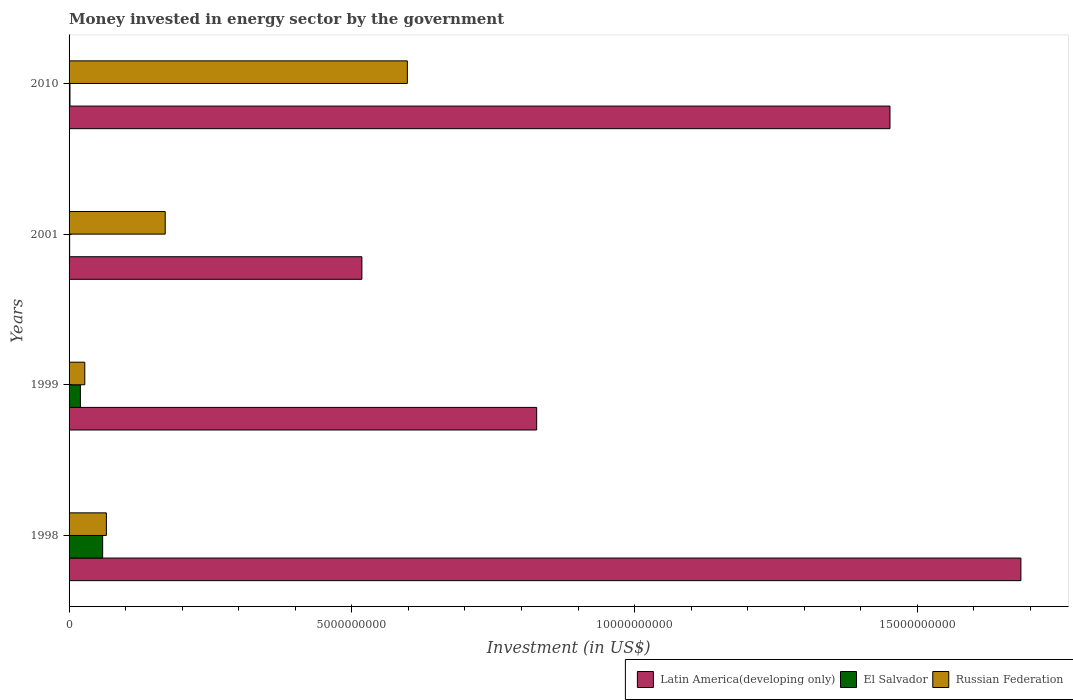What is the money spent in energy sector in Latin America(developing only) in 2001?
Ensure brevity in your answer.  5.18e+09. Across all years, what is the maximum money spent in energy sector in Russian Federation?
Give a very brief answer. 5.98e+09. In which year was the money spent in energy sector in Russian Federation maximum?
Your answer should be very brief. 2010. What is the total money spent in energy sector in El Salvador in the graph?
Your response must be concise. 8.20e+08. What is the difference between the money spent in energy sector in Latin America(developing only) in 1999 and that in 2001?
Your answer should be compact. 3.09e+09. What is the difference between the money spent in energy sector in Latin America(developing only) in 1998 and the money spent in energy sector in El Salvador in 2001?
Provide a short and direct response. 1.68e+1. What is the average money spent in energy sector in El Salvador per year?
Your answer should be compact. 2.05e+08. In the year 1998, what is the difference between the money spent in energy sector in El Salvador and money spent in energy sector in Russian Federation?
Your answer should be compact. -6.60e+07. In how many years, is the money spent in energy sector in Russian Federation greater than 9000000000 US$?
Provide a succinct answer. 0. What is the ratio of the money spent in energy sector in El Salvador in 1999 to that in 2001?
Ensure brevity in your answer.  20.02. Is the difference between the money spent in energy sector in El Salvador in 1999 and 2001 greater than the difference between the money spent in energy sector in Russian Federation in 1999 and 2001?
Your answer should be compact. Yes. What is the difference between the highest and the second highest money spent in energy sector in El Salvador?
Your answer should be very brief. 3.94e+08. What is the difference between the highest and the lowest money spent in energy sector in El Salvador?
Provide a short and direct response. 5.84e+08. What does the 2nd bar from the top in 1998 represents?
Offer a terse response. El Salvador. What does the 3rd bar from the bottom in 1999 represents?
Keep it short and to the point. Russian Federation. Is it the case that in every year, the sum of the money spent in energy sector in El Salvador and money spent in energy sector in Latin America(developing only) is greater than the money spent in energy sector in Russian Federation?
Offer a terse response. Yes. How many bars are there?
Provide a succinct answer. 12. What is the difference between two consecutive major ticks on the X-axis?
Keep it short and to the point. 5.00e+09. Does the graph contain any zero values?
Offer a very short reply. No. Does the graph contain grids?
Your response must be concise. No. Where does the legend appear in the graph?
Provide a short and direct response. Bottom right. What is the title of the graph?
Provide a short and direct response. Money invested in energy sector by the government. What is the label or title of the X-axis?
Keep it short and to the point. Investment (in US$). What is the label or title of the Y-axis?
Your answer should be compact. Years. What is the Investment (in US$) of Latin America(developing only) in 1998?
Give a very brief answer. 1.68e+1. What is the Investment (in US$) of El Salvador in 1998?
Make the answer very short. 5.94e+08. What is the Investment (in US$) of Russian Federation in 1998?
Provide a short and direct response. 6.60e+08. What is the Investment (in US$) in Latin America(developing only) in 1999?
Keep it short and to the point. 8.27e+09. What is the Investment (in US$) of El Salvador in 1999?
Provide a succinct answer. 2.00e+08. What is the Investment (in US$) in Russian Federation in 1999?
Keep it short and to the point. 2.78e+08. What is the Investment (in US$) of Latin America(developing only) in 2001?
Offer a very short reply. 5.18e+09. What is the Investment (in US$) of Russian Federation in 2001?
Ensure brevity in your answer.  1.70e+09. What is the Investment (in US$) in Latin America(developing only) in 2010?
Keep it short and to the point. 1.45e+1. What is the Investment (in US$) in El Salvador in 2010?
Your answer should be very brief. 1.60e+07. What is the Investment (in US$) in Russian Federation in 2010?
Give a very brief answer. 5.98e+09. Across all years, what is the maximum Investment (in US$) of Latin America(developing only)?
Your answer should be very brief. 1.68e+1. Across all years, what is the maximum Investment (in US$) of El Salvador?
Your response must be concise. 5.94e+08. Across all years, what is the maximum Investment (in US$) in Russian Federation?
Provide a short and direct response. 5.98e+09. Across all years, what is the minimum Investment (in US$) of Latin America(developing only)?
Your answer should be very brief. 5.18e+09. Across all years, what is the minimum Investment (in US$) in El Salvador?
Provide a short and direct response. 1.00e+07. Across all years, what is the minimum Investment (in US$) in Russian Federation?
Your answer should be compact. 2.78e+08. What is the total Investment (in US$) of Latin America(developing only) in the graph?
Your response must be concise. 4.48e+1. What is the total Investment (in US$) of El Salvador in the graph?
Provide a succinct answer. 8.20e+08. What is the total Investment (in US$) in Russian Federation in the graph?
Your answer should be very brief. 8.62e+09. What is the difference between the Investment (in US$) of Latin America(developing only) in 1998 and that in 1999?
Provide a succinct answer. 8.56e+09. What is the difference between the Investment (in US$) in El Salvador in 1998 and that in 1999?
Your answer should be compact. 3.94e+08. What is the difference between the Investment (in US$) of Russian Federation in 1998 and that in 1999?
Provide a succinct answer. 3.82e+08. What is the difference between the Investment (in US$) of Latin America(developing only) in 1998 and that in 2001?
Give a very brief answer. 1.17e+1. What is the difference between the Investment (in US$) in El Salvador in 1998 and that in 2001?
Provide a short and direct response. 5.84e+08. What is the difference between the Investment (in US$) of Russian Federation in 1998 and that in 2001?
Your answer should be very brief. -1.04e+09. What is the difference between the Investment (in US$) of Latin America(developing only) in 1998 and that in 2010?
Your response must be concise. 2.31e+09. What is the difference between the Investment (in US$) in El Salvador in 1998 and that in 2010?
Keep it short and to the point. 5.78e+08. What is the difference between the Investment (in US$) in Russian Federation in 1998 and that in 2010?
Make the answer very short. -5.32e+09. What is the difference between the Investment (in US$) of Latin America(developing only) in 1999 and that in 2001?
Provide a short and direct response. 3.09e+09. What is the difference between the Investment (in US$) of El Salvador in 1999 and that in 2001?
Make the answer very short. 1.90e+08. What is the difference between the Investment (in US$) in Russian Federation in 1999 and that in 2001?
Ensure brevity in your answer.  -1.42e+09. What is the difference between the Investment (in US$) in Latin America(developing only) in 1999 and that in 2010?
Your response must be concise. -6.25e+09. What is the difference between the Investment (in US$) of El Salvador in 1999 and that in 2010?
Ensure brevity in your answer.  1.84e+08. What is the difference between the Investment (in US$) of Russian Federation in 1999 and that in 2010?
Make the answer very short. -5.70e+09. What is the difference between the Investment (in US$) in Latin America(developing only) in 2001 and that in 2010?
Ensure brevity in your answer.  -9.34e+09. What is the difference between the Investment (in US$) in El Salvador in 2001 and that in 2010?
Keep it short and to the point. -6.00e+06. What is the difference between the Investment (in US$) in Russian Federation in 2001 and that in 2010?
Your answer should be very brief. -4.28e+09. What is the difference between the Investment (in US$) in Latin America(developing only) in 1998 and the Investment (in US$) in El Salvador in 1999?
Make the answer very short. 1.66e+1. What is the difference between the Investment (in US$) in Latin America(developing only) in 1998 and the Investment (in US$) in Russian Federation in 1999?
Give a very brief answer. 1.66e+1. What is the difference between the Investment (in US$) of El Salvador in 1998 and the Investment (in US$) of Russian Federation in 1999?
Make the answer very short. 3.16e+08. What is the difference between the Investment (in US$) of Latin America(developing only) in 1998 and the Investment (in US$) of El Salvador in 2001?
Offer a very short reply. 1.68e+1. What is the difference between the Investment (in US$) of Latin America(developing only) in 1998 and the Investment (in US$) of Russian Federation in 2001?
Make the answer very short. 1.51e+1. What is the difference between the Investment (in US$) in El Salvador in 1998 and the Investment (in US$) in Russian Federation in 2001?
Make the answer very short. -1.11e+09. What is the difference between the Investment (in US$) in Latin America(developing only) in 1998 and the Investment (in US$) in El Salvador in 2010?
Ensure brevity in your answer.  1.68e+1. What is the difference between the Investment (in US$) in Latin America(developing only) in 1998 and the Investment (in US$) in Russian Federation in 2010?
Offer a very short reply. 1.08e+1. What is the difference between the Investment (in US$) of El Salvador in 1998 and the Investment (in US$) of Russian Federation in 2010?
Give a very brief answer. -5.39e+09. What is the difference between the Investment (in US$) of Latin America(developing only) in 1999 and the Investment (in US$) of El Salvador in 2001?
Keep it short and to the point. 8.26e+09. What is the difference between the Investment (in US$) in Latin America(developing only) in 1999 and the Investment (in US$) in Russian Federation in 2001?
Make the answer very short. 6.57e+09. What is the difference between the Investment (in US$) in El Salvador in 1999 and the Investment (in US$) in Russian Federation in 2001?
Offer a terse response. -1.50e+09. What is the difference between the Investment (in US$) of Latin America(developing only) in 1999 and the Investment (in US$) of El Salvador in 2010?
Keep it short and to the point. 8.25e+09. What is the difference between the Investment (in US$) in Latin America(developing only) in 1999 and the Investment (in US$) in Russian Federation in 2010?
Ensure brevity in your answer.  2.29e+09. What is the difference between the Investment (in US$) in El Salvador in 1999 and the Investment (in US$) in Russian Federation in 2010?
Provide a succinct answer. -5.78e+09. What is the difference between the Investment (in US$) of Latin America(developing only) in 2001 and the Investment (in US$) of El Salvador in 2010?
Offer a very short reply. 5.16e+09. What is the difference between the Investment (in US$) in Latin America(developing only) in 2001 and the Investment (in US$) in Russian Federation in 2010?
Keep it short and to the point. -8.04e+08. What is the difference between the Investment (in US$) of El Salvador in 2001 and the Investment (in US$) of Russian Federation in 2010?
Provide a short and direct response. -5.97e+09. What is the average Investment (in US$) of Latin America(developing only) per year?
Your answer should be compact. 1.12e+1. What is the average Investment (in US$) of El Salvador per year?
Ensure brevity in your answer.  2.05e+08. What is the average Investment (in US$) of Russian Federation per year?
Offer a very short reply. 2.15e+09. In the year 1998, what is the difference between the Investment (in US$) of Latin America(developing only) and Investment (in US$) of El Salvador?
Make the answer very short. 1.62e+1. In the year 1998, what is the difference between the Investment (in US$) of Latin America(developing only) and Investment (in US$) of Russian Federation?
Offer a very short reply. 1.62e+1. In the year 1998, what is the difference between the Investment (in US$) in El Salvador and Investment (in US$) in Russian Federation?
Your answer should be compact. -6.60e+07. In the year 1999, what is the difference between the Investment (in US$) in Latin America(developing only) and Investment (in US$) in El Salvador?
Make the answer very short. 8.07e+09. In the year 1999, what is the difference between the Investment (in US$) in Latin America(developing only) and Investment (in US$) in Russian Federation?
Keep it short and to the point. 7.99e+09. In the year 1999, what is the difference between the Investment (in US$) in El Salvador and Investment (in US$) in Russian Federation?
Ensure brevity in your answer.  -7.78e+07. In the year 2001, what is the difference between the Investment (in US$) in Latin America(developing only) and Investment (in US$) in El Salvador?
Make the answer very short. 5.17e+09. In the year 2001, what is the difference between the Investment (in US$) of Latin America(developing only) and Investment (in US$) of Russian Federation?
Provide a short and direct response. 3.48e+09. In the year 2001, what is the difference between the Investment (in US$) of El Salvador and Investment (in US$) of Russian Federation?
Your answer should be very brief. -1.69e+09. In the year 2010, what is the difference between the Investment (in US$) in Latin America(developing only) and Investment (in US$) in El Salvador?
Make the answer very short. 1.45e+1. In the year 2010, what is the difference between the Investment (in US$) in Latin America(developing only) and Investment (in US$) in Russian Federation?
Offer a very short reply. 8.53e+09. In the year 2010, what is the difference between the Investment (in US$) in El Salvador and Investment (in US$) in Russian Federation?
Provide a succinct answer. -5.97e+09. What is the ratio of the Investment (in US$) in Latin America(developing only) in 1998 to that in 1999?
Keep it short and to the point. 2.04. What is the ratio of the Investment (in US$) of El Salvador in 1998 to that in 1999?
Offer a terse response. 2.97. What is the ratio of the Investment (in US$) of Russian Federation in 1998 to that in 1999?
Give a very brief answer. 2.37. What is the ratio of the Investment (in US$) of Latin America(developing only) in 1998 to that in 2001?
Offer a terse response. 3.25. What is the ratio of the Investment (in US$) in El Salvador in 1998 to that in 2001?
Offer a very short reply. 59.4. What is the ratio of the Investment (in US$) of Russian Federation in 1998 to that in 2001?
Give a very brief answer. 0.39. What is the ratio of the Investment (in US$) in Latin America(developing only) in 1998 to that in 2010?
Make the answer very short. 1.16. What is the ratio of the Investment (in US$) of El Salvador in 1998 to that in 2010?
Make the answer very short. 37.12. What is the ratio of the Investment (in US$) of Russian Federation in 1998 to that in 2010?
Ensure brevity in your answer.  0.11. What is the ratio of the Investment (in US$) in Latin America(developing only) in 1999 to that in 2001?
Offer a terse response. 1.6. What is the ratio of the Investment (in US$) in El Salvador in 1999 to that in 2001?
Your response must be concise. 20.02. What is the ratio of the Investment (in US$) in Russian Federation in 1999 to that in 2001?
Your response must be concise. 0.16. What is the ratio of the Investment (in US$) in Latin America(developing only) in 1999 to that in 2010?
Keep it short and to the point. 0.57. What is the ratio of the Investment (in US$) in El Salvador in 1999 to that in 2010?
Keep it short and to the point. 12.51. What is the ratio of the Investment (in US$) of Russian Federation in 1999 to that in 2010?
Your answer should be very brief. 0.05. What is the ratio of the Investment (in US$) in Latin America(developing only) in 2001 to that in 2010?
Make the answer very short. 0.36. What is the ratio of the Investment (in US$) in El Salvador in 2001 to that in 2010?
Make the answer very short. 0.62. What is the ratio of the Investment (in US$) in Russian Federation in 2001 to that in 2010?
Your response must be concise. 0.28. What is the difference between the highest and the second highest Investment (in US$) in Latin America(developing only)?
Make the answer very short. 2.31e+09. What is the difference between the highest and the second highest Investment (in US$) of El Salvador?
Your answer should be compact. 3.94e+08. What is the difference between the highest and the second highest Investment (in US$) in Russian Federation?
Keep it short and to the point. 4.28e+09. What is the difference between the highest and the lowest Investment (in US$) in Latin America(developing only)?
Ensure brevity in your answer.  1.17e+1. What is the difference between the highest and the lowest Investment (in US$) of El Salvador?
Your answer should be very brief. 5.84e+08. What is the difference between the highest and the lowest Investment (in US$) in Russian Federation?
Offer a terse response. 5.70e+09. 